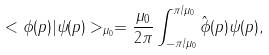<formula> <loc_0><loc_0><loc_500><loc_500>< \phi ( p ) | \psi ( p ) > _ { \mu _ { 0 } } = \frac { \mu _ { 0 } } { 2 \pi } \int ^ { \pi / \mu _ { 0 } } _ { - \pi / \mu _ { 0 } } \hat { \phi } ( p ) \psi ( p ) ,</formula> 